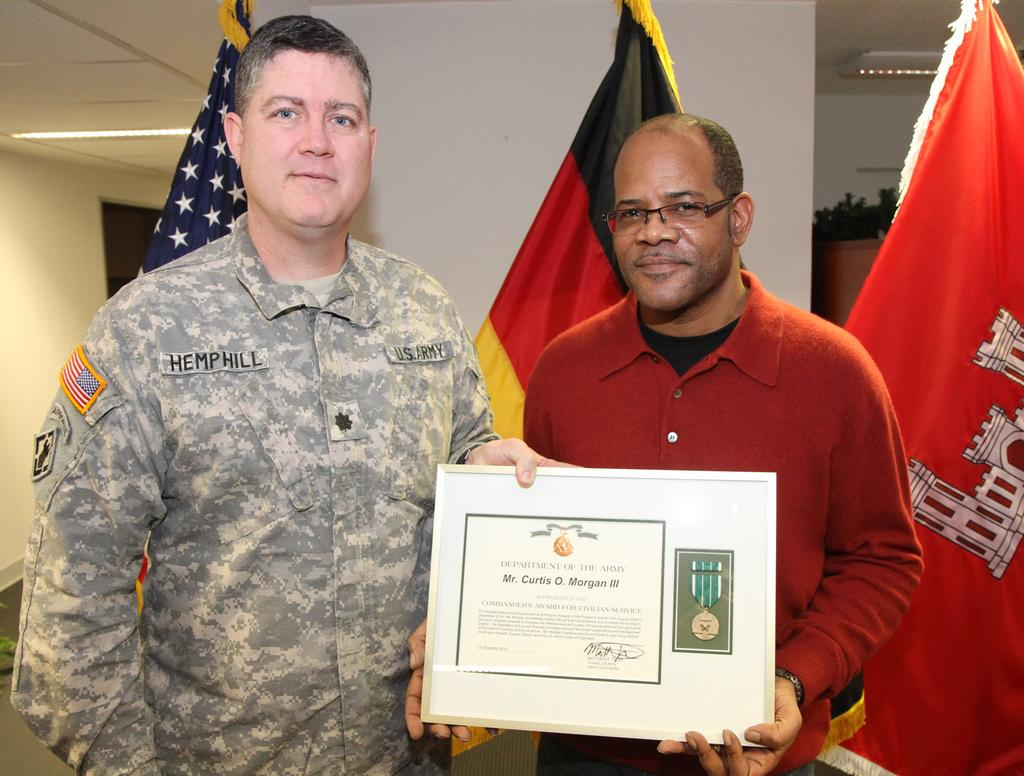How many people are present in the image? There are two men in the image. What are the men holding in their hands? The men are holding an award in their hands. What can be seen in the background of the image? There are three flags and a wall in the background of the image. What type of tomatoes are being used as an example in the image? There are no tomatoes present in the image. Is there a hospital visible in the image? There is no hospital visible in the image. 